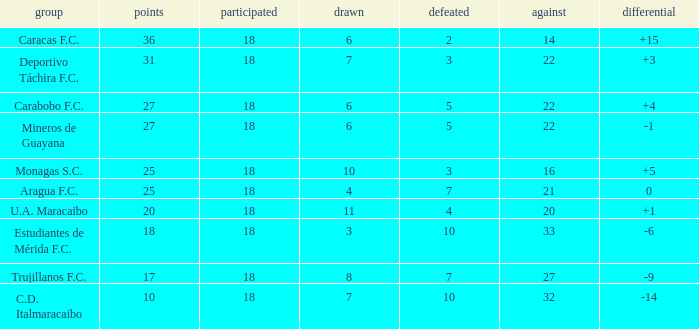What is the typical against score for all teams with under 7 losses, above 6 draws, and 25 points? 16.0. 